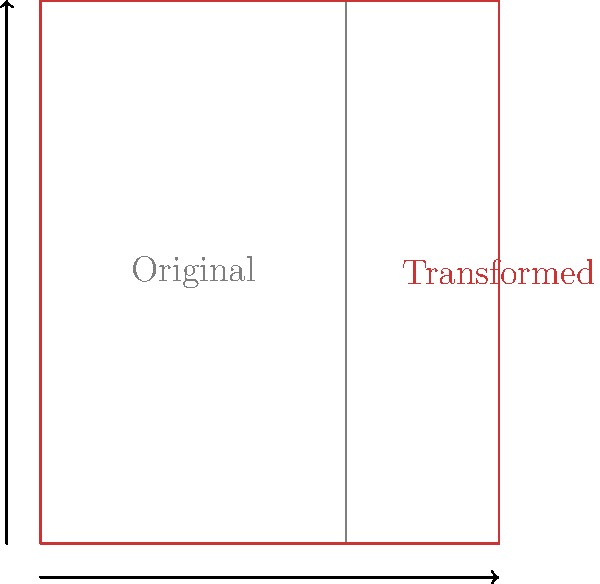As a dedicated iPhone user, you're analyzing the screen aspect ratio changes. If an iPhone's screen dimensions are transformed by scaling horizontally by a factor of 1.5 while maintaining the vertical dimension, what is the new aspect ratio? Express your answer as a simplified fraction. Let's approach this step-by-step:

1. The original iPhone aspect ratio is typically 9:16.

2. The transformation scales the horizontal dimension by 1.5:
   New width = $9 \times 1.5 = 13.5$

3. The vertical dimension remains unchanged at 16.

4. The new aspect ratio is thus 13.5:16

5. To simplify this ratio, we need to find the greatest common divisor (GCD) of 13.5 and 16:
   $GCD(13.5, 16) = 0.5$

6. Dividing both terms by 0.5:
   $\frac{13.5}{0.5} : \frac{16}{0.5} = 27:32$

Therefore, the new simplified aspect ratio is 27:32.
Answer: 27:32 